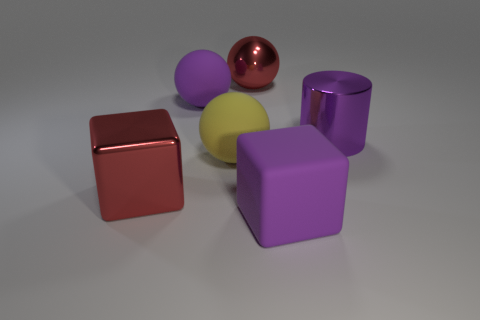Subtract all big purple balls. How many balls are left? 2 Add 2 yellow things. How many objects exist? 8 Subtract 1 cubes. How many cubes are left? 1 Subtract all red balls. How many balls are left? 2 Subtract all cubes. How many objects are left? 4 Add 4 yellow rubber things. How many yellow rubber things exist? 5 Subtract 0 red cylinders. How many objects are left? 6 Subtract all blue cylinders. Subtract all cyan spheres. How many cylinders are left? 1 Subtract all big red metal spheres. Subtract all red blocks. How many objects are left? 4 Add 1 matte blocks. How many matte blocks are left? 2 